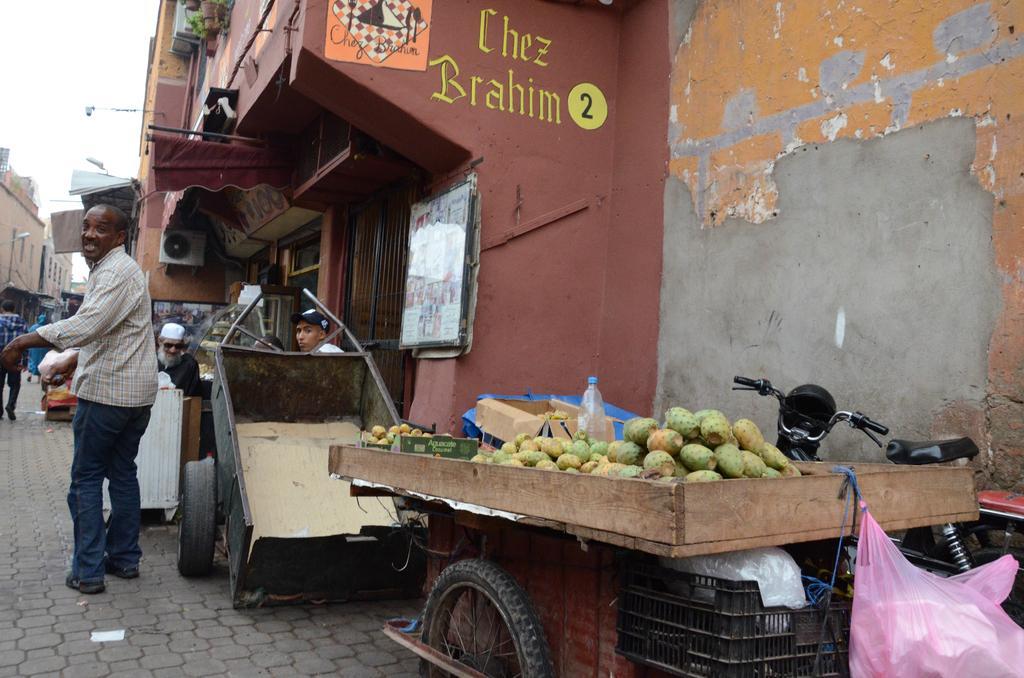How would you summarize this image in a sentence or two? In the center of the image we can see the trolleys. On the trolley we can see the fruits, containers, bottle, plastic covers. In the background of the image we can see the buildings, text on the wall, board on the wall, air conditioner, pots, plants, lights. On the left side of the image we can see some people are walking on the pavement and some of them are sitting. At the bottom of the image we can see the pavement. In the top left corner we can see the sky and light. 